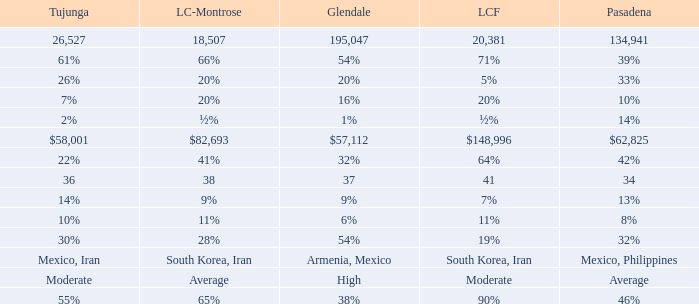What is the figure for Tujunga when Pasadena is 134,941? 26527.0. 